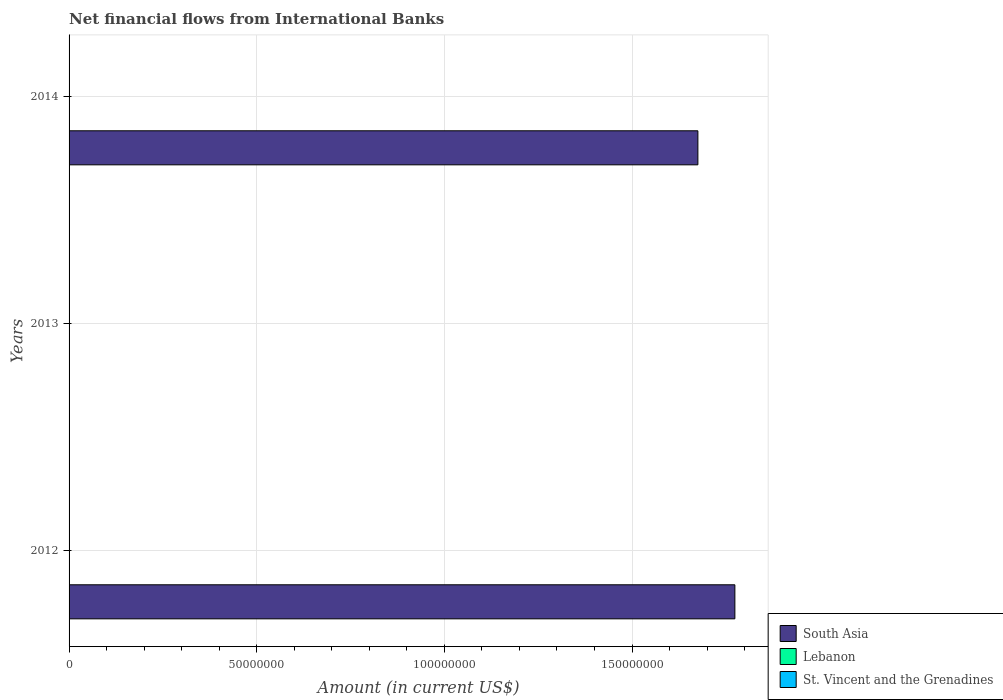How many different coloured bars are there?
Offer a terse response. 1. In how many cases, is the number of bars for a given year not equal to the number of legend labels?
Give a very brief answer. 3. Across all years, what is the maximum net financial aid flows in South Asia?
Your response must be concise. 1.77e+08. Across all years, what is the minimum net financial aid flows in Lebanon?
Provide a short and direct response. 0. What is the total net financial aid flows in South Asia in the graph?
Make the answer very short. 3.45e+08. What is the difference between the net financial aid flows in South Asia in 2012 and that in 2014?
Offer a terse response. 9.85e+06. What is the difference between the net financial aid flows in South Asia in 2014 and the net financial aid flows in Lebanon in 2013?
Give a very brief answer. 1.68e+08. In how many years, is the net financial aid flows in St. Vincent and the Grenadines greater than 150000000 US$?
Your response must be concise. 0. What is the ratio of the net financial aid flows in South Asia in 2012 to that in 2014?
Your answer should be compact. 1.06. What is the difference between the highest and the lowest net financial aid flows in South Asia?
Your response must be concise. 1.77e+08. Is it the case that in every year, the sum of the net financial aid flows in Lebanon and net financial aid flows in South Asia is greater than the net financial aid flows in St. Vincent and the Grenadines?
Ensure brevity in your answer.  No. How many bars are there?
Give a very brief answer. 2. Does the graph contain any zero values?
Your response must be concise. Yes. Where does the legend appear in the graph?
Your answer should be compact. Bottom right. What is the title of the graph?
Make the answer very short. Net financial flows from International Banks. What is the label or title of the Y-axis?
Your answer should be very brief. Years. What is the Amount (in current US$) in South Asia in 2012?
Offer a very short reply. 1.77e+08. What is the Amount (in current US$) of South Asia in 2013?
Ensure brevity in your answer.  0. What is the Amount (in current US$) in St. Vincent and the Grenadines in 2013?
Give a very brief answer. 0. What is the Amount (in current US$) of South Asia in 2014?
Ensure brevity in your answer.  1.68e+08. What is the Amount (in current US$) in Lebanon in 2014?
Provide a succinct answer. 0. Across all years, what is the maximum Amount (in current US$) in South Asia?
Your response must be concise. 1.77e+08. What is the total Amount (in current US$) in South Asia in the graph?
Offer a terse response. 3.45e+08. What is the total Amount (in current US$) of Lebanon in the graph?
Keep it short and to the point. 0. What is the difference between the Amount (in current US$) of South Asia in 2012 and that in 2014?
Your answer should be compact. 9.85e+06. What is the average Amount (in current US$) in South Asia per year?
Offer a very short reply. 1.15e+08. What is the average Amount (in current US$) of St. Vincent and the Grenadines per year?
Ensure brevity in your answer.  0. What is the ratio of the Amount (in current US$) of South Asia in 2012 to that in 2014?
Provide a succinct answer. 1.06. What is the difference between the highest and the lowest Amount (in current US$) of South Asia?
Give a very brief answer. 1.77e+08. 